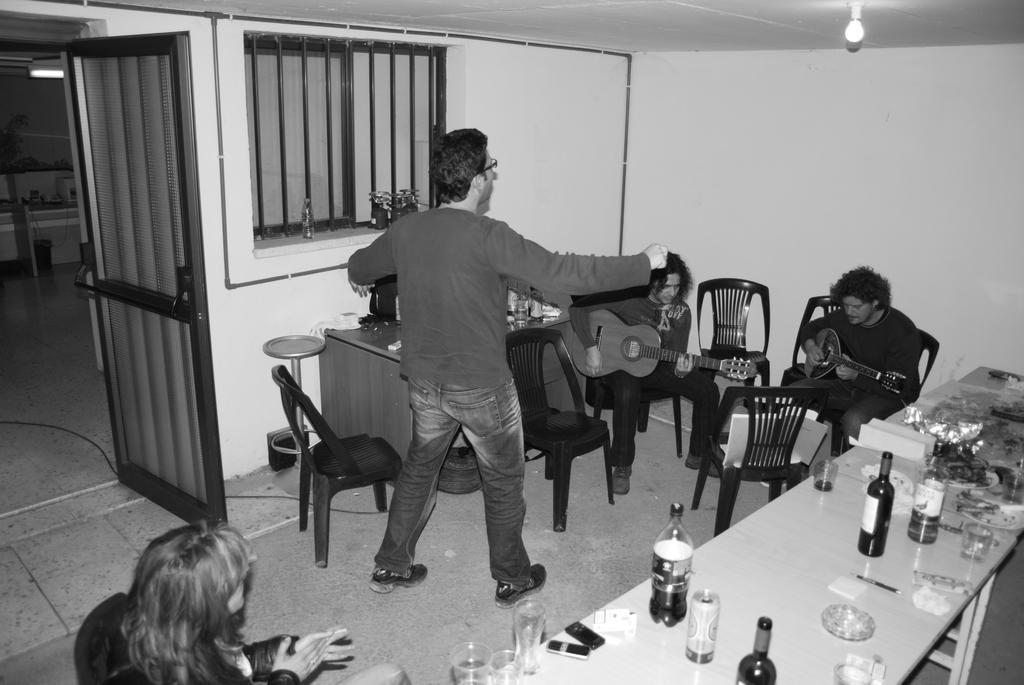In one or two sentences, can you explain what this image depicts? This is a black and white picture. In this picture we can see objects placed in the shelves. We can see lights, windows, door and chairs. We can see people playing musical instruments and a man is dancing. At the bottom we can see a person and a chair. On the tables we can see bottles, glasses, mobiles and few other objects. 